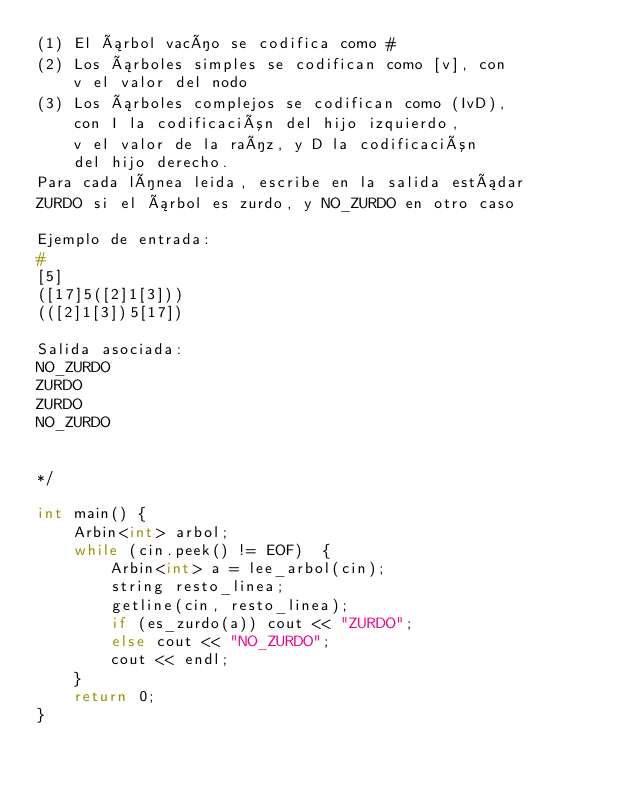Convert code to text. <code><loc_0><loc_0><loc_500><loc_500><_C++_>(1) El árbol vacío se codifica como #
(2) Los árboles simples se codifican como [v], con  
    v el valor del nodo
(3) Los árboles complejos se codifican como (IvD),
    con I la codificación del hijo izquierdo,
	v el valor de la raíz, y D la codificación
	del hijo derecho.
Para cada línea leida, escribe en la salida estádar
ZURDO si el árbol es zurdo, y NO_ZURDO en otro caso

Ejemplo de entrada:
#
[5]
([17]5([2]1[3]))
(([2]1[3])5[17])

Salida asociada:
NO_ZURDO
ZURDO
ZURDO
NO_ZURDO


*/

int main() {
	Arbin<int> arbol;
	while (cin.peek() != EOF)  {
		Arbin<int> a = lee_arbol(cin);
		string resto_linea;
		getline(cin, resto_linea);
		if (es_zurdo(a)) cout << "ZURDO";
		else cout << "NO_ZURDO";
		cout << endl;
	}
	return 0;
}
</code> 